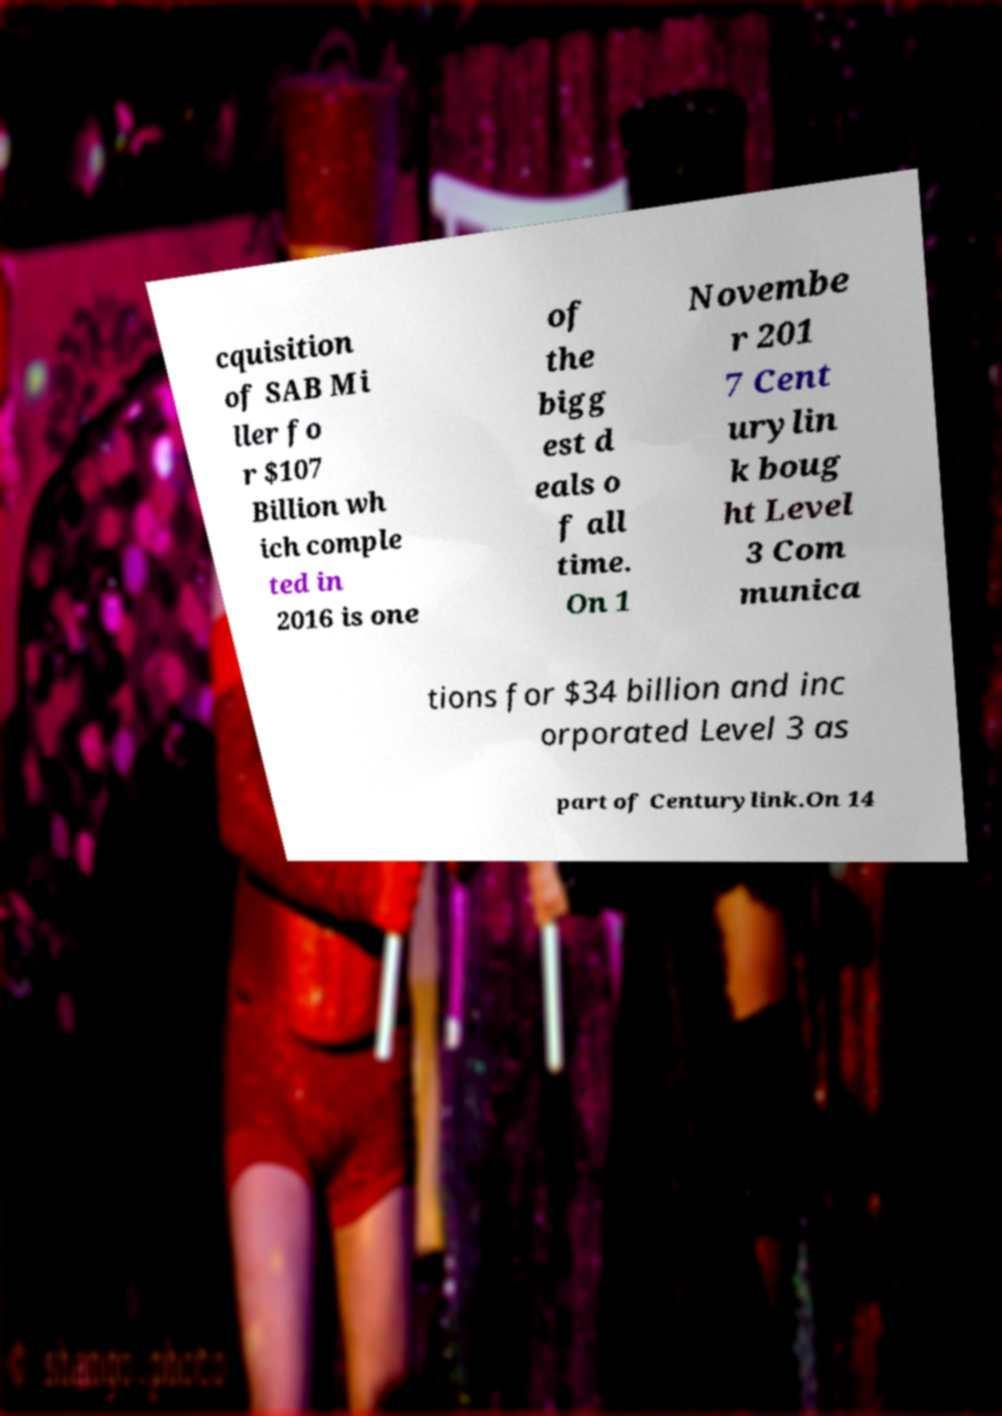What messages or text are displayed in this image? I need them in a readable, typed format. cquisition of SAB Mi ller fo r $107 Billion wh ich comple ted in 2016 is one of the bigg est d eals o f all time. On 1 Novembe r 201 7 Cent urylin k boug ht Level 3 Com munica tions for $34 billion and inc orporated Level 3 as part of Centurylink.On 14 